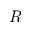<formula> <loc_0><loc_0><loc_500><loc_500>R</formula> 